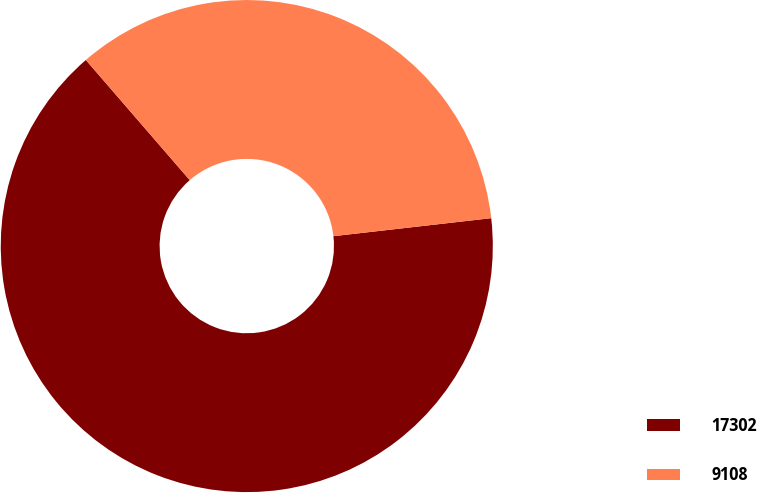Convert chart. <chart><loc_0><loc_0><loc_500><loc_500><pie_chart><fcel>17302<fcel>9108<nl><fcel>65.46%<fcel>34.54%<nl></chart> 